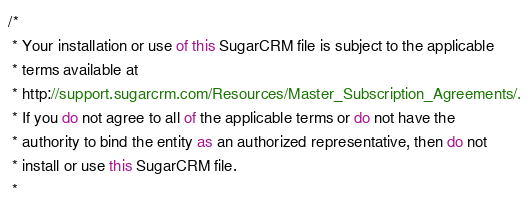<code> <loc_0><loc_0><loc_500><loc_500><_JavaScript_>/*
 * Your installation or use of this SugarCRM file is subject to the applicable
 * terms available at
 * http://support.sugarcrm.com/Resources/Master_Subscription_Agreements/.
 * If you do not agree to all of the applicable terms or do not have the
 * authority to bind the entity as an authorized representative, then do not
 * install or use this SugarCRM file.
 *</code> 